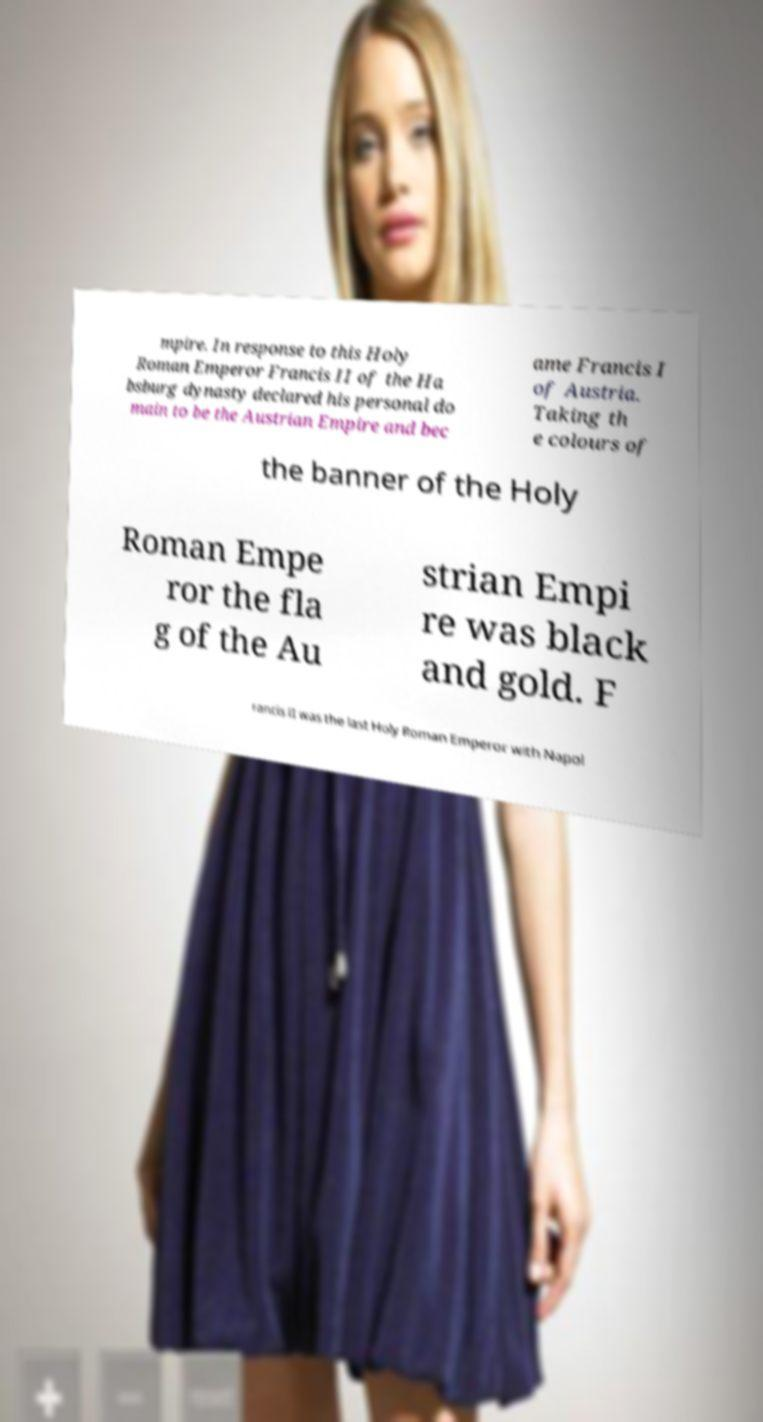What messages or text are displayed in this image? I need them in a readable, typed format. mpire. In response to this Holy Roman Emperor Francis II of the Ha bsburg dynasty declared his personal do main to be the Austrian Empire and bec ame Francis I of Austria. Taking th e colours of the banner of the Holy Roman Empe ror the fla g of the Au strian Empi re was black and gold. F rancis II was the last Holy Roman Emperor with Napol 